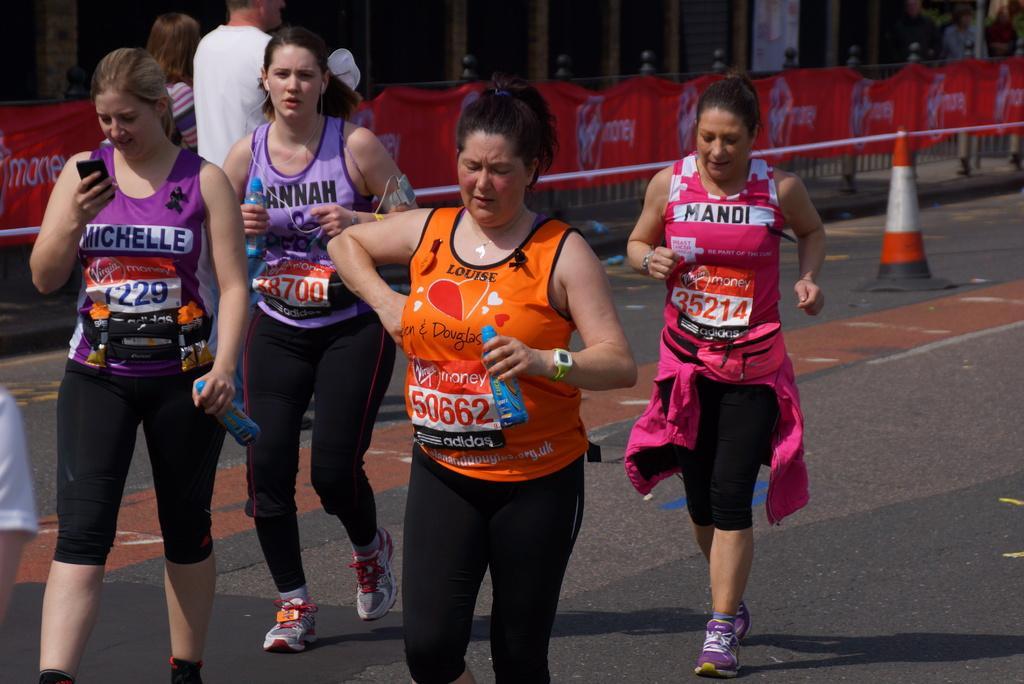In one or two sentences, can you explain what this image depicts? In this image I can see the group of people with different color dresses. These people are on the road. I can see three people holding the bottle and one person holding the mobile To the left I can see the traffic cone and the banner to the railing. In the background I can see the building. 